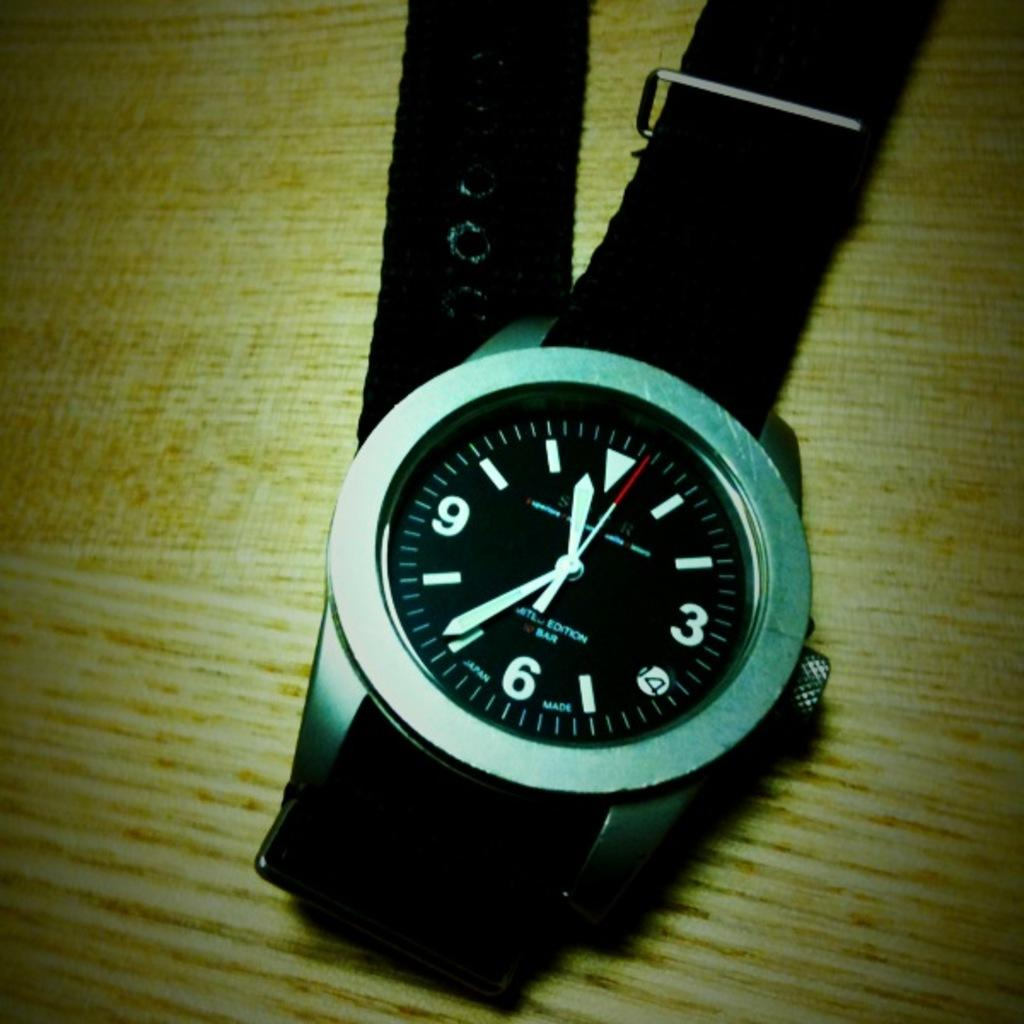<image>
Write a terse but informative summary of the picture. The black faced watch with a black band shows the time of 11:36. 